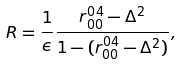<formula> <loc_0><loc_0><loc_500><loc_500>R = \frac { 1 } { \epsilon } \frac { r ^ { 0 4 } _ { 0 0 } - \Delta ^ { 2 } } { 1 - ( r ^ { 0 4 } _ { 0 0 } - \Delta ^ { 2 } ) } ,</formula> 